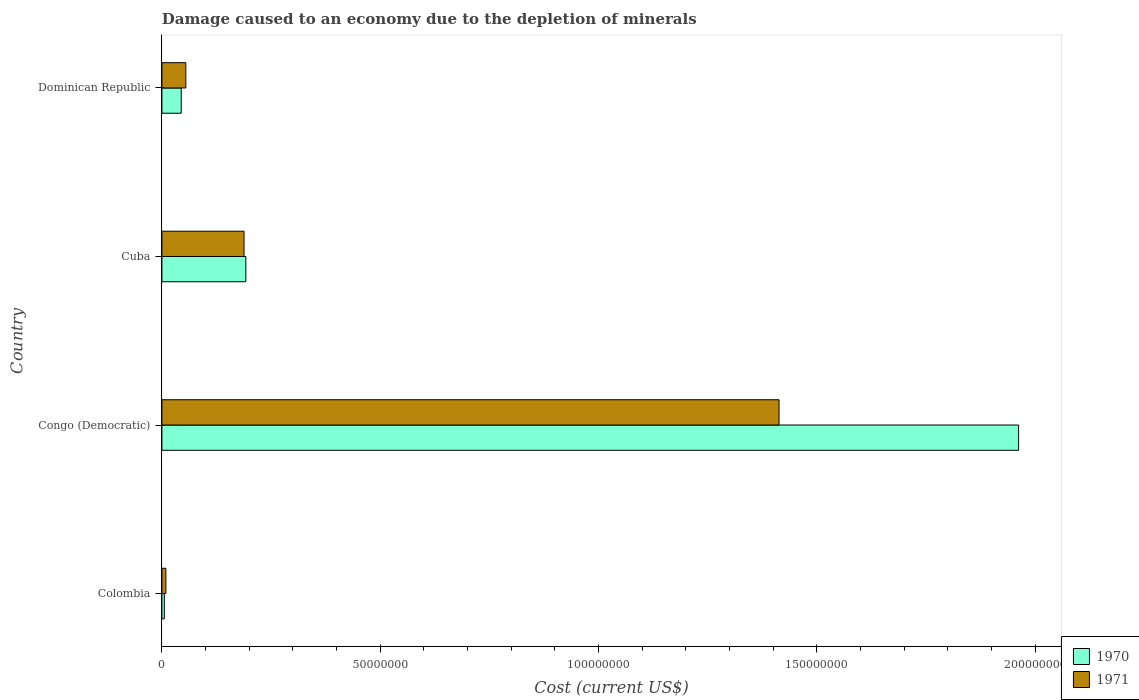How many different coloured bars are there?
Offer a very short reply. 2. How many bars are there on the 3rd tick from the bottom?
Offer a terse response. 2. What is the label of the 4th group of bars from the top?
Your answer should be compact. Colombia. What is the cost of damage caused due to the depletion of minerals in 1970 in Congo (Democratic)?
Ensure brevity in your answer.  1.96e+08. Across all countries, what is the maximum cost of damage caused due to the depletion of minerals in 1971?
Provide a succinct answer. 1.41e+08. Across all countries, what is the minimum cost of damage caused due to the depletion of minerals in 1971?
Ensure brevity in your answer.  9.12e+05. In which country was the cost of damage caused due to the depletion of minerals in 1971 maximum?
Offer a terse response. Congo (Democratic). In which country was the cost of damage caused due to the depletion of minerals in 1971 minimum?
Make the answer very short. Colombia. What is the total cost of damage caused due to the depletion of minerals in 1971 in the graph?
Keep it short and to the point. 1.67e+08. What is the difference between the cost of damage caused due to the depletion of minerals in 1971 in Colombia and that in Congo (Democratic)?
Your answer should be very brief. -1.40e+08. What is the difference between the cost of damage caused due to the depletion of minerals in 1970 in Cuba and the cost of damage caused due to the depletion of minerals in 1971 in Dominican Republic?
Give a very brief answer. 1.37e+07. What is the average cost of damage caused due to the depletion of minerals in 1970 per country?
Your answer should be compact. 5.51e+07. What is the difference between the cost of damage caused due to the depletion of minerals in 1971 and cost of damage caused due to the depletion of minerals in 1970 in Cuba?
Provide a short and direct response. -4.14e+05. What is the ratio of the cost of damage caused due to the depletion of minerals in 1971 in Congo (Democratic) to that in Dominican Republic?
Your answer should be compact. 25.8. Is the difference between the cost of damage caused due to the depletion of minerals in 1971 in Congo (Democratic) and Dominican Republic greater than the difference between the cost of damage caused due to the depletion of minerals in 1970 in Congo (Democratic) and Dominican Republic?
Offer a terse response. No. What is the difference between the highest and the second highest cost of damage caused due to the depletion of minerals in 1970?
Provide a short and direct response. 1.77e+08. What is the difference between the highest and the lowest cost of damage caused due to the depletion of minerals in 1970?
Give a very brief answer. 1.96e+08. What does the 1st bar from the bottom in Cuba represents?
Your answer should be compact. 1970. How many bars are there?
Your answer should be compact. 8. What is the difference between two consecutive major ticks on the X-axis?
Keep it short and to the point. 5.00e+07. Are the values on the major ticks of X-axis written in scientific E-notation?
Ensure brevity in your answer.  No. Does the graph contain any zero values?
Your answer should be very brief. No. Where does the legend appear in the graph?
Your answer should be very brief. Bottom right. What is the title of the graph?
Provide a succinct answer. Damage caused to an economy due to the depletion of minerals. Does "1975" appear as one of the legend labels in the graph?
Make the answer very short. No. What is the label or title of the X-axis?
Offer a terse response. Cost (current US$). What is the Cost (current US$) in 1970 in Colombia?
Your response must be concise. 5.53e+05. What is the Cost (current US$) of 1971 in Colombia?
Provide a short and direct response. 9.12e+05. What is the Cost (current US$) of 1970 in Congo (Democratic)?
Your answer should be very brief. 1.96e+08. What is the Cost (current US$) of 1971 in Congo (Democratic)?
Provide a short and direct response. 1.41e+08. What is the Cost (current US$) of 1970 in Cuba?
Your answer should be very brief. 1.92e+07. What is the Cost (current US$) in 1971 in Cuba?
Give a very brief answer. 1.88e+07. What is the Cost (current US$) of 1970 in Dominican Republic?
Make the answer very short. 4.43e+06. What is the Cost (current US$) in 1971 in Dominican Republic?
Your response must be concise. 5.48e+06. Across all countries, what is the maximum Cost (current US$) in 1970?
Offer a terse response. 1.96e+08. Across all countries, what is the maximum Cost (current US$) of 1971?
Your response must be concise. 1.41e+08. Across all countries, what is the minimum Cost (current US$) in 1970?
Provide a succinct answer. 5.53e+05. Across all countries, what is the minimum Cost (current US$) in 1971?
Keep it short and to the point. 9.12e+05. What is the total Cost (current US$) of 1970 in the graph?
Provide a short and direct response. 2.20e+08. What is the total Cost (current US$) of 1971 in the graph?
Your response must be concise. 1.67e+08. What is the difference between the Cost (current US$) in 1970 in Colombia and that in Congo (Democratic)?
Your answer should be compact. -1.96e+08. What is the difference between the Cost (current US$) in 1971 in Colombia and that in Congo (Democratic)?
Your answer should be very brief. -1.40e+08. What is the difference between the Cost (current US$) in 1970 in Colombia and that in Cuba?
Keep it short and to the point. -1.87e+07. What is the difference between the Cost (current US$) in 1971 in Colombia and that in Cuba?
Keep it short and to the point. -1.79e+07. What is the difference between the Cost (current US$) in 1970 in Colombia and that in Dominican Republic?
Your answer should be very brief. -3.87e+06. What is the difference between the Cost (current US$) of 1971 in Colombia and that in Dominican Republic?
Your answer should be very brief. -4.57e+06. What is the difference between the Cost (current US$) of 1970 in Congo (Democratic) and that in Cuba?
Provide a short and direct response. 1.77e+08. What is the difference between the Cost (current US$) of 1971 in Congo (Democratic) and that in Cuba?
Ensure brevity in your answer.  1.23e+08. What is the difference between the Cost (current US$) in 1970 in Congo (Democratic) and that in Dominican Republic?
Your answer should be very brief. 1.92e+08. What is the difference between the Cost (current US$) of 1971 in Congo (Democratic) and that in Dominican Republic?
Offer a very short reply. 1.36e+08. What is the difference between the Cost (current US$) in 1970 in Cuba and that in Dominican Republic?
Ensure brevity in your answer.  1.48e+07. What is the difference between the Cost (current US$) in 1971 in Cuba and that in Dominican Republic?
Your answer should be very brief. 1.33e+07. What is the difference between the Cost (current US$) in 1970 in Colombia and the Cost (current US$) in 1971 in Congo (Democratic)?
Offer a terse response. -1.41e+08. What is the difference between the Cost (current US$) of 1970 in Colombia and the Cost (current US$) of 1971 in Cuba?
Make the answer very short. -1.83e+07. What is the difference between the Cost (current US$) in 1970 in Colombia and the Cost (current US$) in 1971 in Dominican Republic?
Provide a short and direct response. -4.93e+06. What is the difference between the Cost (current US$) in 1970 in Congo (Democratic) and the Cost (current US$) in 1971 in Cuba?
Make the answer very short. 1.77e+08. What is the difference between the Cost (current US$) in 1970 in Congo (Democratic) and the Cost (current US$) in 1971 in Dominican Republic?
Keep it short and to the point. 1.91e+08. What is the difference between the Cost (current US$) of 1970 in Cuba and the Cost (current US$) of 1971 in Dominican Republic?
Keep it short and to the point. 1.37e+07. What is the average Cost (current US$) of 1970 per country?
Offer a very short reply. 5.51e+07. What is the average Cost (current US$) of 1971 per country?
Your answer should be compact. 4.16e+07. What is the difference between the Cost (current US$) in 1970 and Cost (current US$) in 1971 in Colombia?
Provide a succinct answer. -3.59e+05. What is the difference between the Cost (current US$) in 1970 and Cost (current US$) in 1971 in Congo (Democratic)?
Provide a succinct answer. 5.49e+07. What is the difference between the Cost (current US$) of 1970 and Cost (current US$) of 1971 in Cuba?
Offer a terse response. 4.14e+05. What is the difference between the Cost (current US$) in 1970 and Cost (current US$) in 1971 in Dominican Republic?
Your answer should be very brief. -1.05e+06. What is the ratio of the Cost (current US$) in 1970 in Colombia to that in Congo (Democratic)?
Offer a terse response. 0. What is the ratio of the Cost (current US$) in 1971 in Colombia to that in Congo (Democratic)?
Your answer should be very brief. 0.01. What is the ratio of the Cost (current US$) of 1970 in Colombia to that in Cuba?
Provide a short and direct response. 0.03. What is the ratio of the Cost (current US$) in 1971 in Colombia to that in Cuba?
Your answer should be very brief. 0.05. What is the ratio of the Cost (current US$) of 1970 in Colombia to that in Dominican Republic?
Your answer should be very brief. 0.12. What is the ratio of the Cost (current US$) in 1971 in Colombia to that in Dominican Republic?
Provide a short and direct response. 0.17. What is the ratio of the Cost (current US$) in 1970 in Congo (Democratic) to that in Cuba?
Give a very brief answer. 10.21. What is the ratio of the Cost (current US$) in 1971 in Congo (Democratic) to that in Cuba?
Make the answer very short. 7.51. What is the ratio of the Cost (current US$) in 1970 in Congo (Democratic) to that in Dominican Republic?
Provide a succinct answer. 44.31. What is the ratio of the Cost (current US$) of 1971 in Congo (Democratic) to that in Dominican Republic?
Give a very brief answer. 25.8. What is the ratio of the Cost (current US$) in 1970 in Cuba to that in Dominican Republic?
Your response must be concise. 4.34. What is the ratio of the Cost (current US$) of 1971 in Cuba to that in Dominican Republic?
Offer a very short reply. 3.43. What is the difference between the highest and the second highest Cost (current US$) of 1970?
Offer a terse response. 1.77e+08. What is the difference between the highest and the second highest Cost (current US$) of 1971?
Provide a short and direct response. 1.23e+08. What is the difference between the highest and the lowest Cost (current US$) in 1970?
Your response must be concise. 1.96e+08. What is the difference between the highest and the lowest Cost (current US$) in 1971?
Provide a short and direct response. 1.40e+08. 